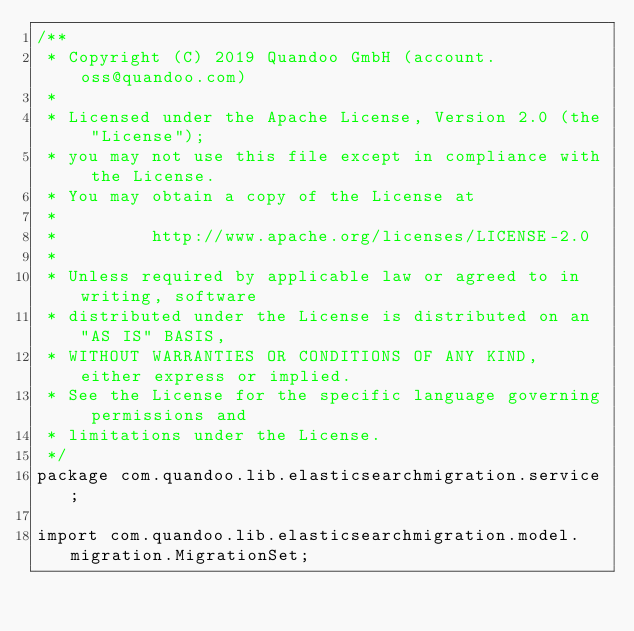Convert code to text. <code><loc_0><loc_0><loc_500><loc_500><_Java_>/**
 * Copyright (C) 2019 Quandoo GmbH (account.oss@quandoo.com)
 *
 * Licensed under the Apache License, Version 2.0 (the "License");
 * you may not use this file except in compliance with the License.
 * You may obtain a copy of the License at
 *
 *         http://www.apache.org/licenses/LICENSE-2.0
 *
 * Unless required by applicable law or agreed to in writing, software
 * distributed under the License is distributed on an "AS IS" BASIS,
 * WITHOUT WARRANTIES OR CONDITIONS OF ANY KIND, either express or implied.
 * See the License for the specific language governing permissions and
 * limitations under the License.
 */
package com.quandoo.lib.elasticsearchmigration.service;

import com.quandoo.lib.elasticsearchmigration.model.migration.MigrationSet;
</code> 